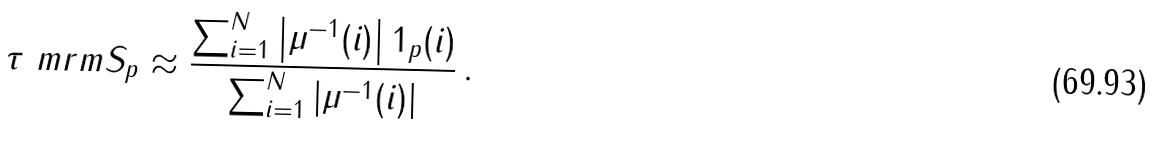<formula> <loc_0><loc_0><loc_500><loc_500>\tau ^ { \ } m r m { S } _ { p } \approx \frac { \sum _ { i = 1 } ^ { N } \left | \mu ^ { - 1 } ( i ) \right | 1 _ { p } ( i ) } { \sum _ { i = 1 } ^ { N } \left | \mu ^ { - 1 } ( i ) \right | } \, .</formula> 